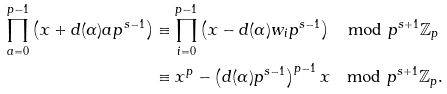Convert formula to latex. <formula><loc_0><loc_0><loc_500><loc_500>\prod _ { a = 0 } ^ { p - 1 } \left ( x + d ( \alpha ) a p ^ { s - 1 } \right ) & \equiv \prod _ { i = 0 } ^ { p - 1 } \left ( x - d ( \alpha ) w _ { i } p ^ { s - 1 } \right ) \mod p ^ { s + 1 } \mathbb { Z } _ { p } \\ & \equiv x ^ { p } - \left ( d ( \alpha ) p ^ { s - 1 } \right ) ^ { p - 1 } x \mod p ^ { s + 1 } \mathbb { Z } _ { p } .</formula> 